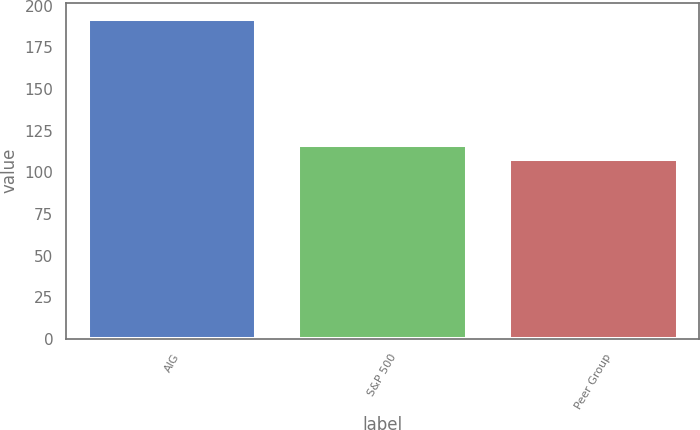Convert chart. <chart><loc_0><loc_0><loc_500><loc_500><bar_chart><fcel>AIG<fcel>S&P 500<fcel>Peer Group<nl><fcel>192.19<fcel>116.44<fcel>108.02<nl></chart> 